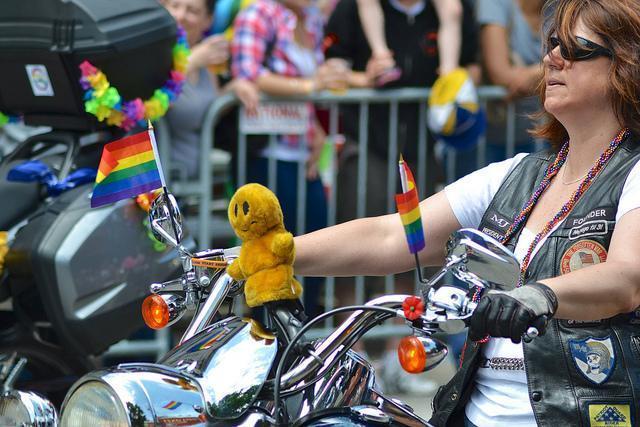How many people are in the picture?
Give a very brief answer. 4. How many clocks have red numbers?
Give a very brief answer. 0. 